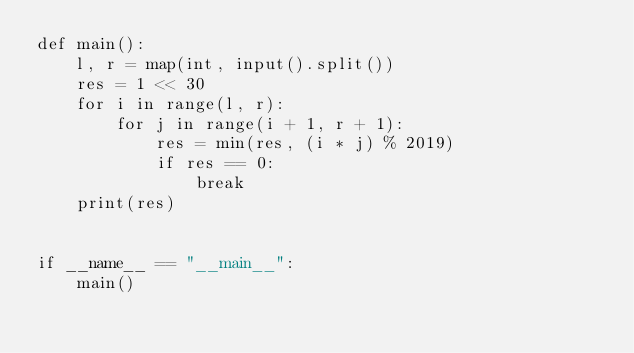<code> <loc_0><loc_0><loc_500><loc_500><_Python_>def main():
    l, r = map(int, input().split())
    res = 1 << 30
    for i in range(l, r):
        for j in range(i + 1, r + 1):
            res = min(res, (i * j) % 2019)
            if res == 0:
                break
    print(res)


if __name__ == "__main__":
    main()
</code> 